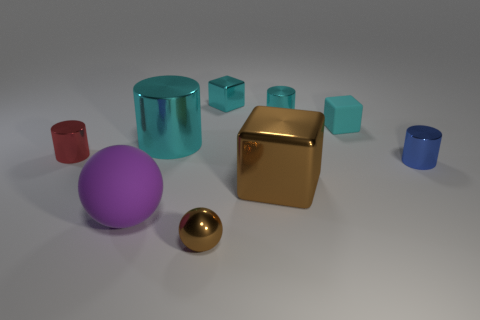Can you describe the lighting and shadows in the scene? Certainly. The lighting in this scene comes from above, as indicated by the shadows cast directly under the objects. The shadows are soft-edged, suggesting a diffuse light source, not unlike a cloudy day where the sunlight is scattered by the atmosphere. The general ambiance is soft and lacks harsh contrasts, creating a calm and balanced visual experience. 